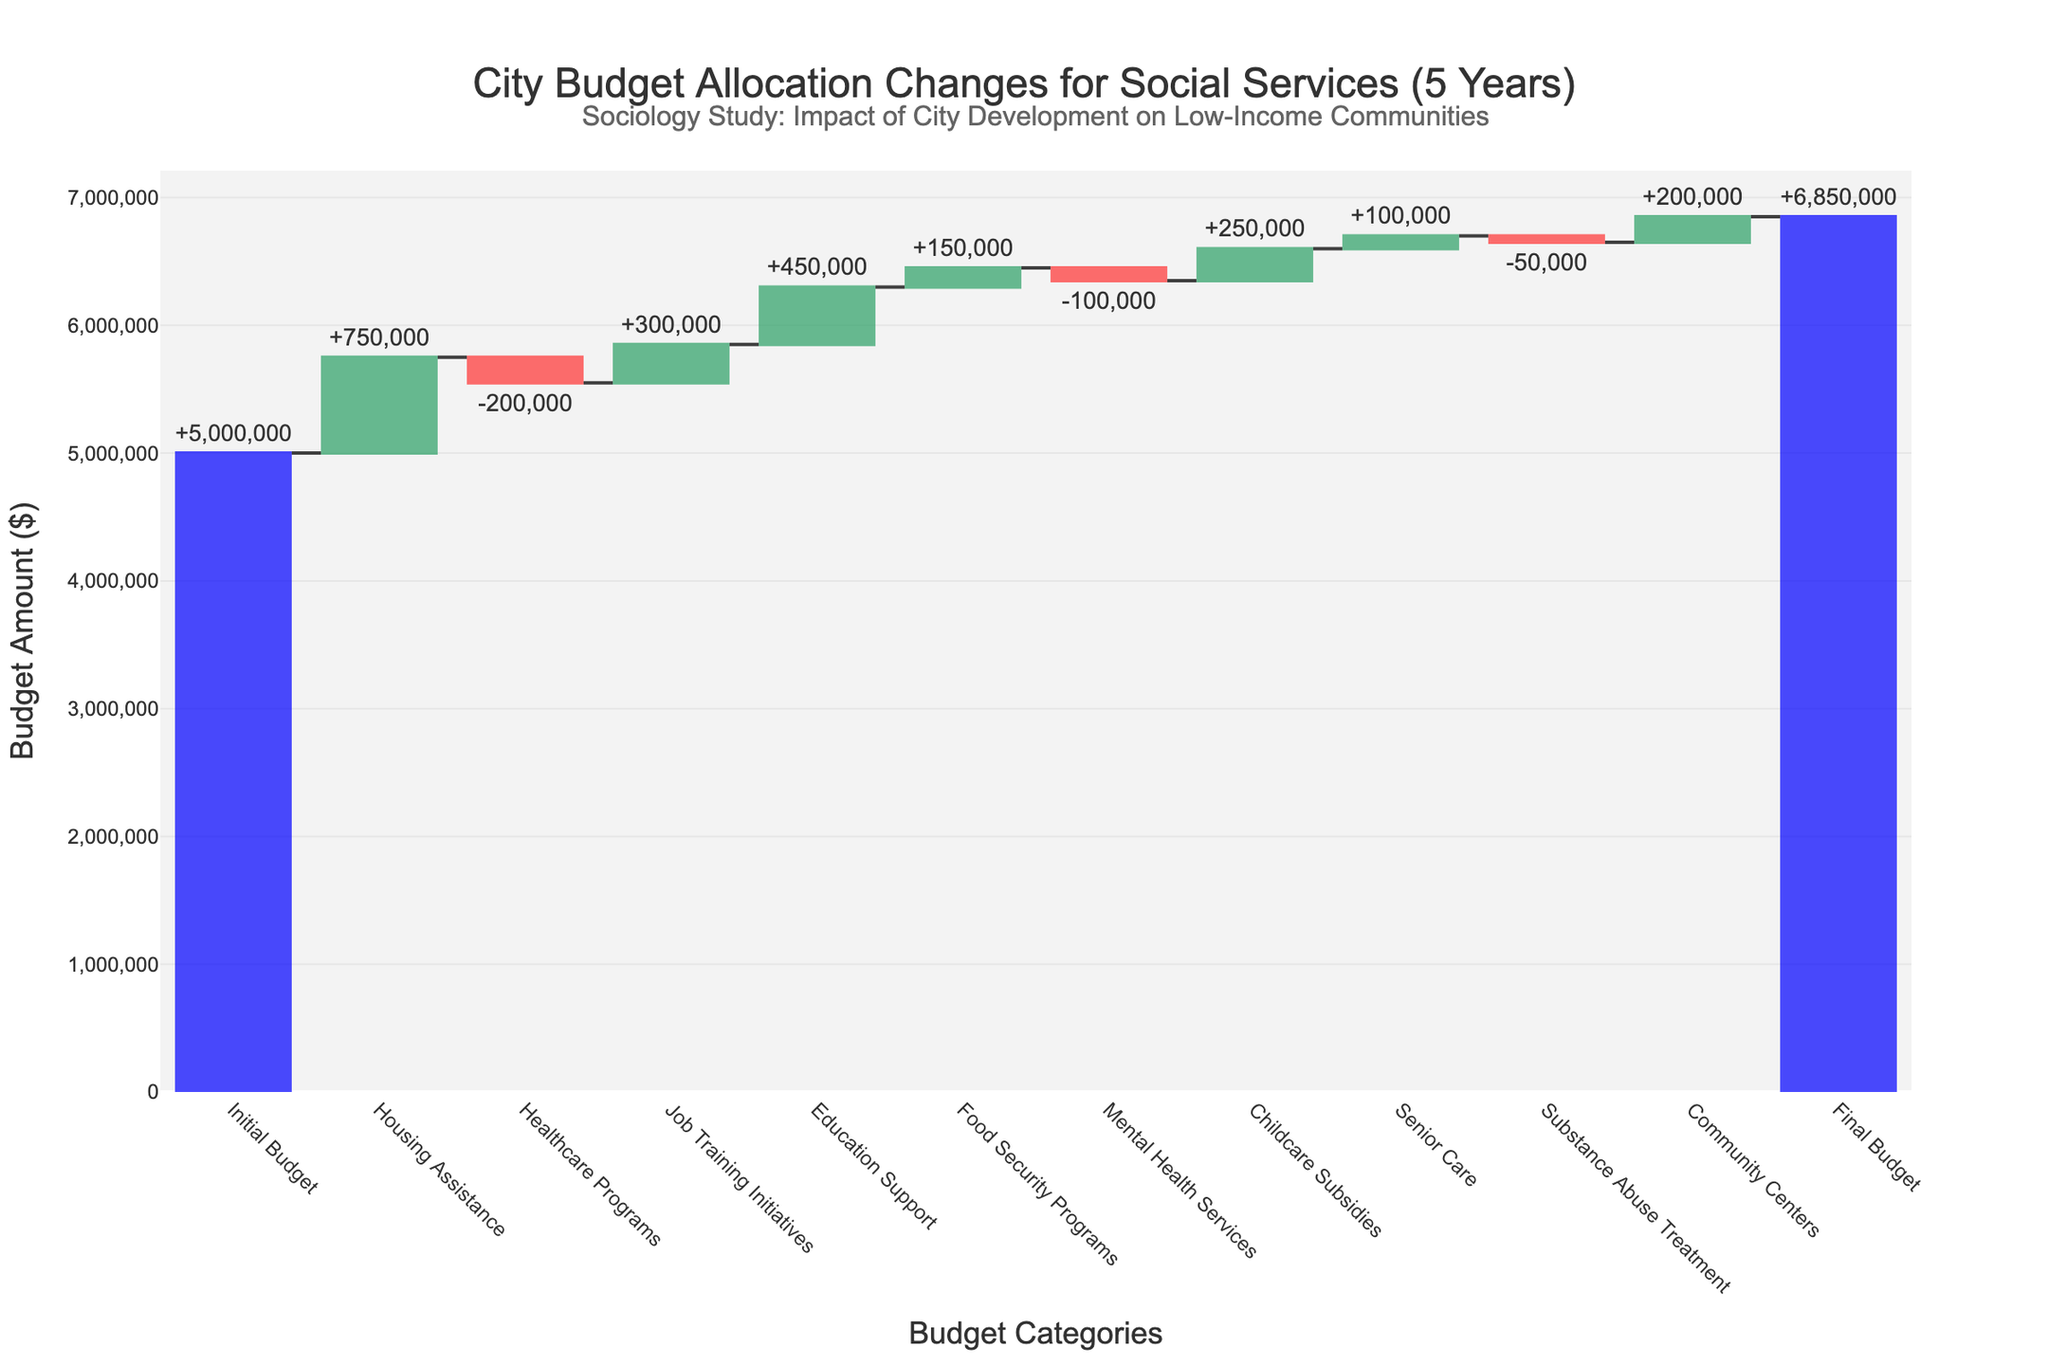What is the initial budget amount? The initial budget amount is stated as the first entry in the plot. It shows the starting point of the budget allocation.
Answer: $5,000,000 What is the final budget amount? The final budget amount is represented as the last bar in the plot, summarizing all the changes applied to the initial budget.
Answer: $6,850,000 Which category saw the greatest increase in budget allocation? By looking for the tallest positive bar (green) in the plot, you can identify which social service category received the largest increase.
Answer: Housing Assistance Which category experienced the largest decrease in budget allocation? Similarly, by finding the tallest negative bar (red), you can determine the category with the most significant decrease in budget.
Answer: Healthcare Programs What is the total amount of budget increase across all categories? Add up all the positive changes shown in the waterfall chart. These include Housing Assistance, Job Training Initiatives, Education Support, Food Security Programs, Childcare Subsidies, Senior Care, and Community Centers.
Answer: $2,200,000 What is the total amount of budget decrease across all categories? Sum up the negative changes illustrated in the chart, which are Healthcare Programs, Mental Health Services, and Substance Abuse Treatment.
Answer: $350,000 How much did the budget for Education Support change? Locate the bar labeled Education Support in the chart and note the change indicated.
Answer: $450,000 What is the net change in the budget after considering both increases and decreases? Subtract the total decreases from the total increases and add this net change to the initial budget. First, calculate $2,200,000 (increases) - $350,000 (decreases) = $1,850,000 (net change). Then add this to the initial budget: $5,000,000 + $1,850,000.
Answer: $1,850,000 Does the final budget align with the cumulative changes shown in the intermediate steps? Confirm that the sum of all increases and decreases plus the initial budget matches the final budget. Initial Budget ($5,000,000) + Total Increases ($2,200,000) - Total Decreases ($350,000) = Final Budget ($6,850,000).
Answer: Yes 